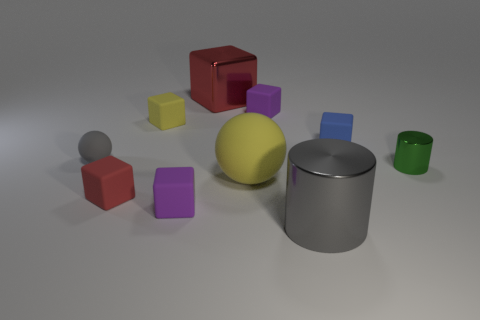How many small spheres have the same color as the big cylinder?
Ensure brevity in your answer.  1. How many other objects are the same color as the shiny block?
Provide a succinct answer. 1. What color is the other thing that is the same shape as the green object?
Provide a short and direct response. Gray. What is the shape of the rubber thing on the right side of the gray shiny cylinder?
Offer a terse response. Cube. How many blue objects have the same shape as the big yellow rubber object?
Make the answer very short. 0. There is a ball that is behind the green metal object; is its color the same as the big thing that is in front of the big rubber object?
Keep it short and to the point. Yes. What number of objects are either red matte blocks or spheres?
Offer a terse response. 3. How many large red cubes have the same material as the tiny green thing?
Offer a terse response. 1. Are there fewer red cylinders than small yellow blocks?
Offer a very short reply. Yes. Is the material of the blue thing behind the small red thing the same as the tiny red cube?
Your response must be concise. Yes. 